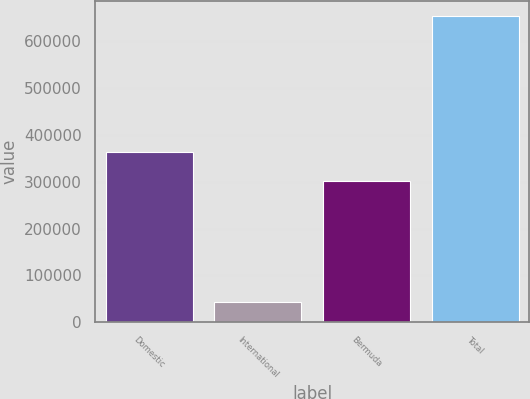<chart> <loc_0><loc_0><loc_500><loc_500><bar_chart><fcel>Domestic<fcel>International<fcel>Bermuda<fcel>Total<nl><fcel>363038<fcel>44088<fcel>302101<fcel>653463<nl></chart> 